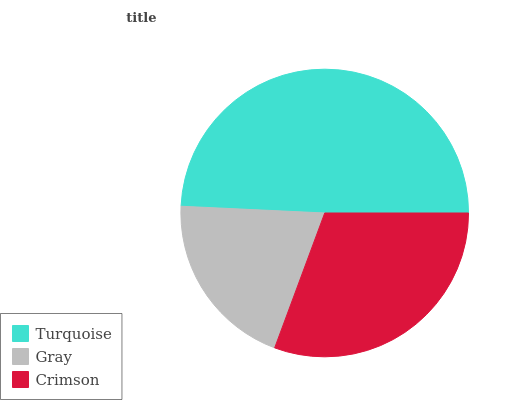Is Gray the minimum?
Answer yes or no. Yes. Is Turquoise the maximum?
Answer yes or no. Yes. Is Crimson the minimum?
Answer yes or no. No. Is Crimson the maximum?
Answer yes or no. No. Is Crimson greater than Gray?
Answer yes or no. Yes. Is Gray less than Crimson?
Answer yes or no. Yes. Is Gray greater than Crimson?
Answer yes or no. No. Is Crimson less than Gray?
Answer yes or no. No. Is Crimson the high median?
Answer yes or no. Yes. Is Crimson the low median?
Answer yes or no. Yes. Is Turquoise the high median?
Answer yes or no. No. Is Turquoise the low median?
Answer yes or no. No. 